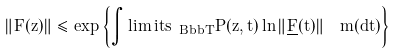Convert formula to latex. <formula><loc_0><loc_0><loc_500><loc_500>\| F ( z ) \| \leq \exp \left \{ \int \lim i t s _ { \ B b b T } P ( z , t ) \ln { \| \underline { F } ( t ) \| } \ \ m ( d t ) \right \}</formula> 